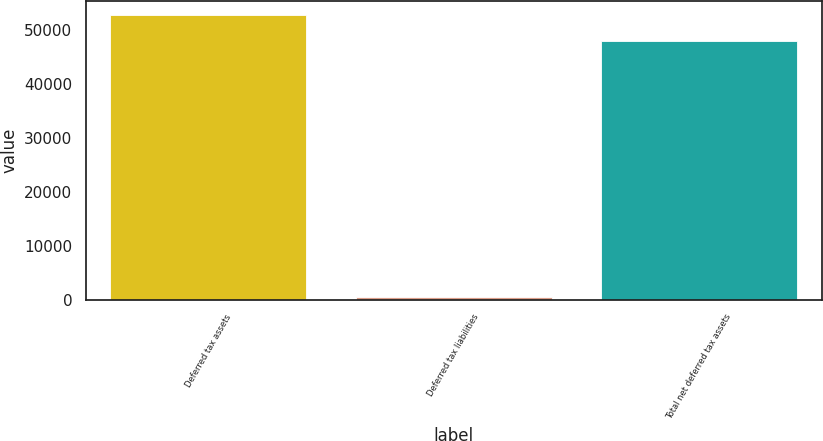Convert chart. <chart><loc_0><loc_0><loc_500><loc_500><bar_chart><fcel>Deferred tax assets<fcel>Deferred tax liabilities<fcel>Total net deferred tax assets<nl><fcel>52756<fcel>469<fcel>47960<nl></chart> 